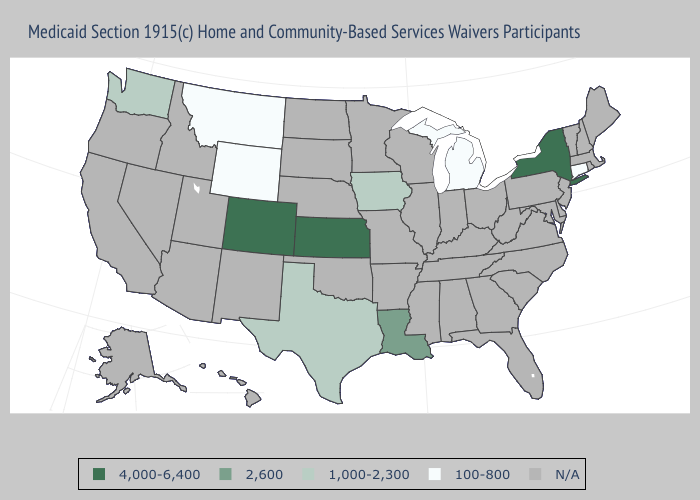How many symbols are there in the legend?
Keep it brief. 5. What is the lowest value in the USA?
Give a very brief answer. 100-800. What is the value of Louisiana?
Short answer required. 2,600. What is the highest value in states that border Minnesota?
Keep it brief. 1,000-2,300. What is the value of Iowa?
Concise answer only. 1,000-2,300. Name the states that have a value in the range 100-800?
Concise answer only. Connecticut, Michigan, Montana, Wyoming. Does New York have the highest value in the USA?
Short answer required. Yes. Among the states that border Montana , which have the highest value?
Give a very brief answer. Wyoming. Among the states that border Oklahoma , which have the highest value?
Quick response, please. Colorado, Kansas. What is the value of New Jersey?
Keep it brief. N/A. Is the legend a continuous bar?
Answer briefly. No. Name the states that have a value in the range 2,600?
Concise answer only. Louisiana. 